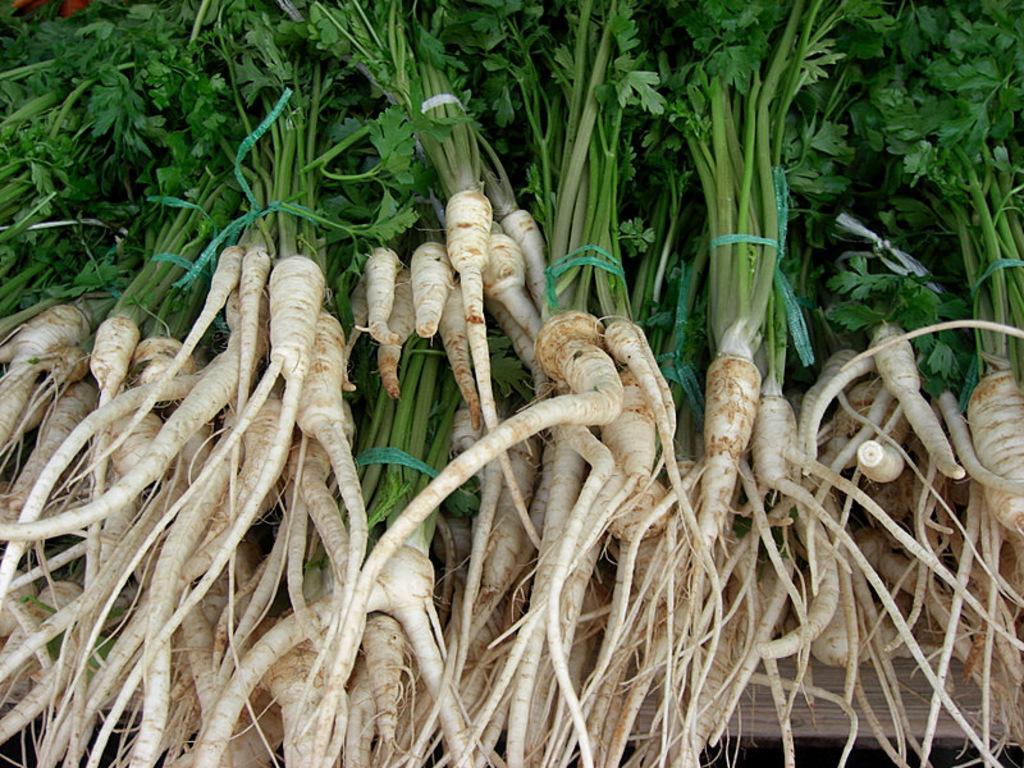How would you summarize this image in a sentence or two? In this picture I can see there is a green leafy vegetables placed on a table and it has some white color object attached to its roots. 